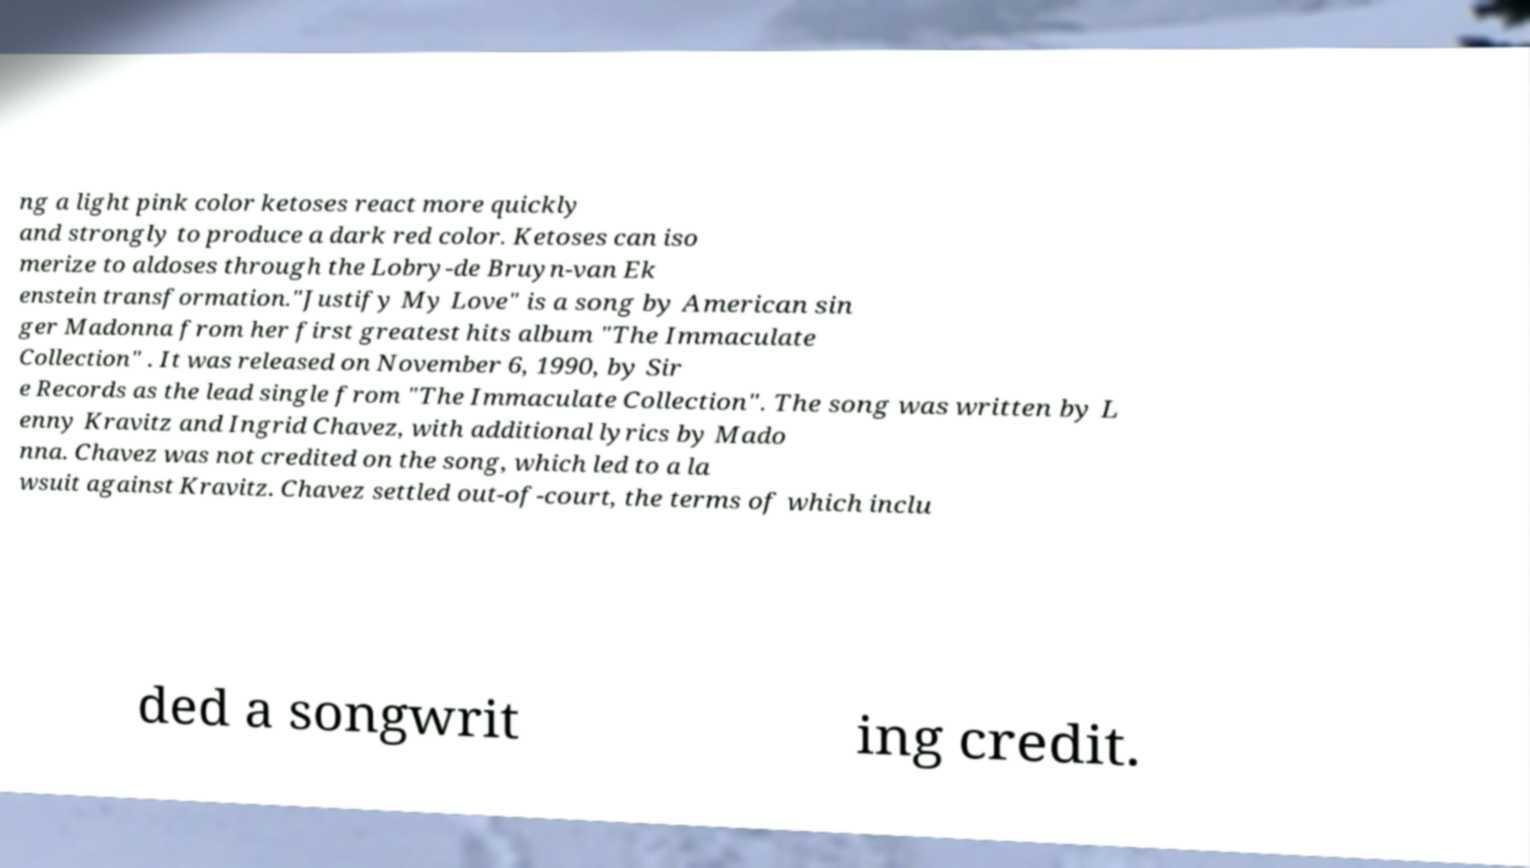Please read and relay the text visible in this image. What does it say? ng a light pink color ketoses react more quickly and strongly to produce a dark red color. Ketoses can iso merize to aldoses through the Lobry-de Bruyn-van Ek enstein transformation."Justify My Love" is a song by American sin ger Madonna from her first greatest hits album "The Immaculate Collection" . It was released on November 6, 1990, by Sir e Records as the lead single from "The Immaculate Collection". The song was written by L enny Kravitz and Ingrid Chavez, with additional lyrics by Mado nna. Chavez was not credited on the song, which led to a la wsuit against Kravitz. Chavez settled out-of-court, the terms of which inclu ded a songwrit ing credit. 